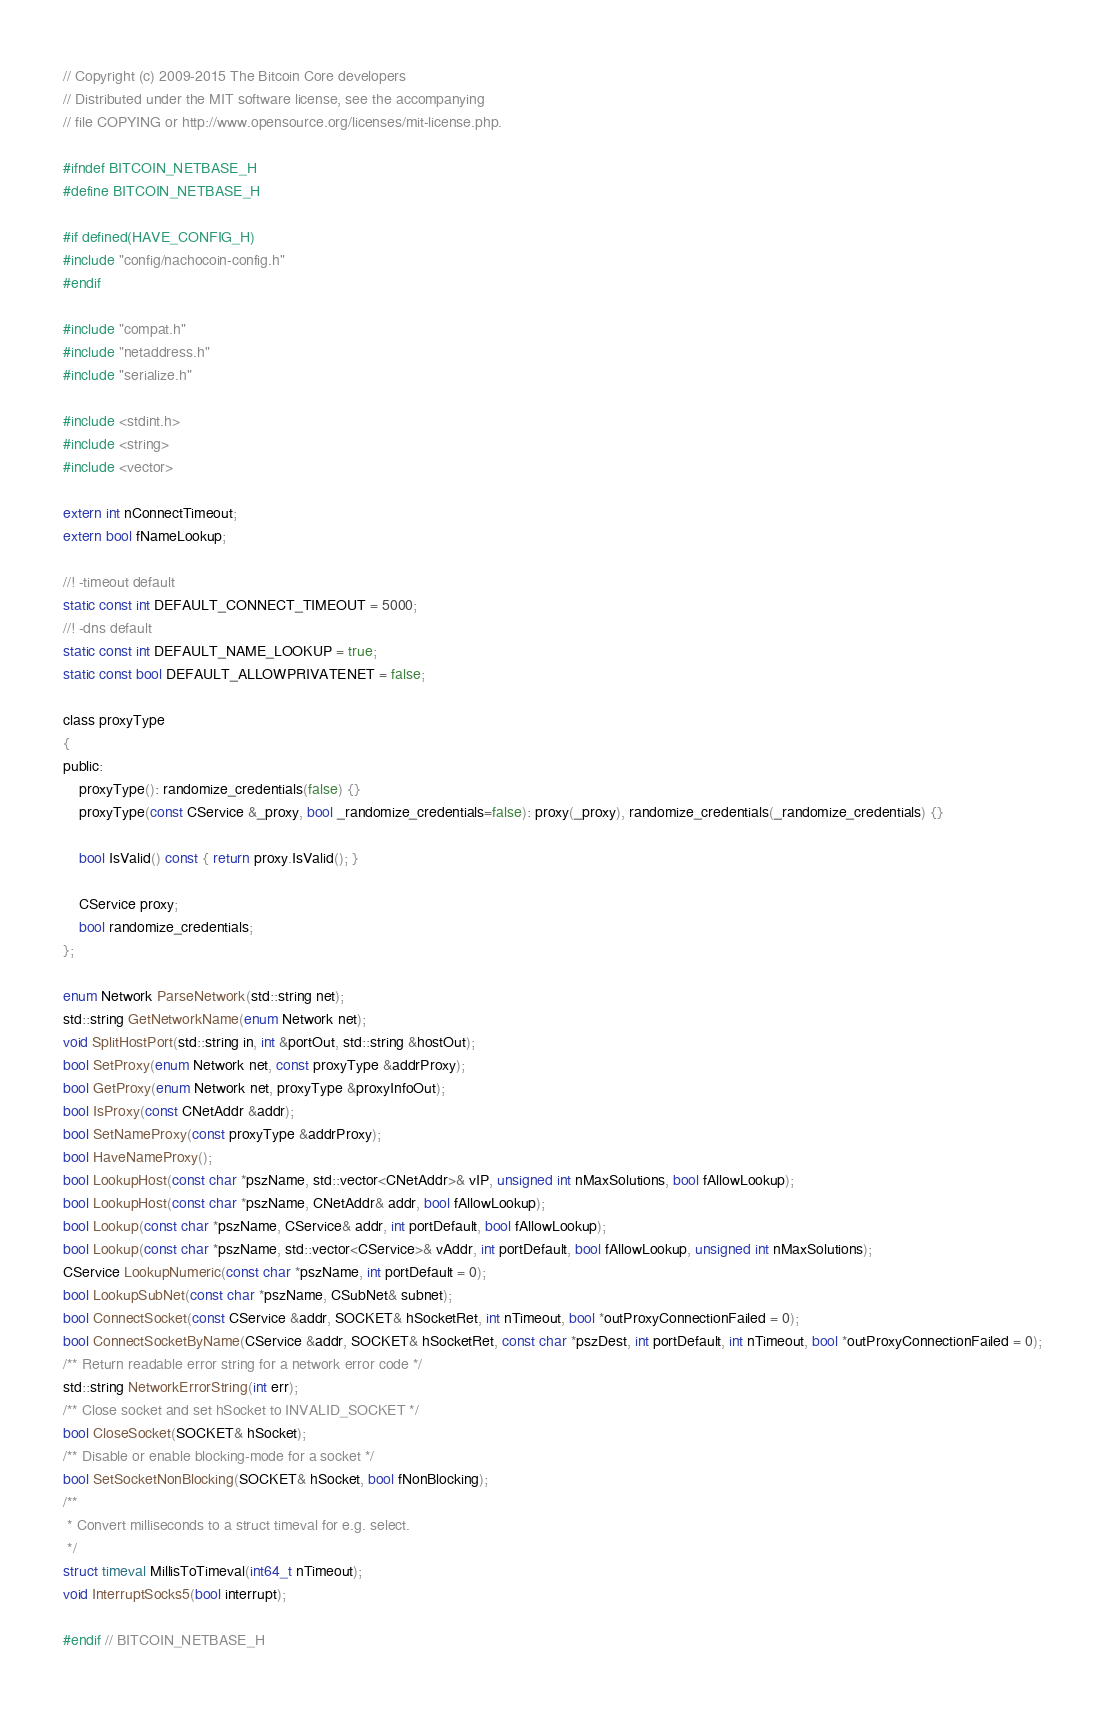Convert code to text. <code><loc_0><loc_0><loc_500><loc_500><_C_>// Copyright (c) 2009-2015 The Bitcoin Core developers
// Distributed under the MIT software license, see the accompanying
// file COPYING or http://www.opensource.org/licenses/mit-license.php.

#ifndef BITCOIN_NETBASE_H
#define BITCOIN_NETBASE_H

#if defined(HAVE_CONFIG_H)
#include "config/nachocoin-config.h"
#endif

#include "compat.h"
#include "netaddress.h"
#include "serialize.h"

#include <stdint.h>
#include <string>
#include <vector>

extern int nConnectTimeout;
extern bool fNameLookup;

//! -timeout default
static const int DEFAULT_CONNECT_TIMEOUT = 5000;
//! -dns default
static const int DEFAULT_NAME_LOOKUP = true;
static const bool DEFAULT_ALLOWPRIVATENET = false;

class proxyType
{
public:
    proxyType(): randomize_credentials(false) {}
    proxyType(const CService &_proxy, bool _randomize_credentials=false): proxy(_proxy), randomize_credentials(_randomize_credentials) {}

    bool IsValid() const { return proxy.IsValid(); }

    CService proxy;
    bool randomize_credentials;
};

enum Network ParseNetwork(std::string net);
std::string GetNetworkName(enum Network net);
void SplitHostPort(std::string in, int &portOut, std::string &hostOut);
bool SetProxy(enum Network net, const proxyType &addrProxy);
bool GetProxy(enum Network net, proxyType &proxyInfoOut);
bool IsProxy(const CNetAddr &addr);
bool SetNameProxy(const proxyType &addrProxy);
bool HaveNameProxy();
bool LookupHost(const char *pszName, std::vector<CNetAddr>& vIP, unsigned int nMaxSolutions, bool fAllowLookup);
bool LookupHost(const char *pszName, CNetAddr& addr, bool fAllowLookup);
bool Lookup(const char *pszName, CService& addr, int portDefault, bool fAllowLookup);
bool Lookup(const char *pszName, std::vector<CService>& vAddr, int portDefault, bool fAllowLookup, unsigned int nMaxSolutions);
CService LookupNumeric(const char *pszName, int portDefault = 0);
bool LookupSubNet(const char *pszName, CSubNet& subnet);
bool ConnectSocket(const CService &addr, SOCKET& hSocketRet, int nTimeout, bool *outProxyConnectionFailed = 0);
bool ConnectSocketByName(CService &addr, SOCKET& hSocketRet, const char *pszDest, int portDefault, int nTimeout, bool *outProxyConnectionFailed = 0);
/** Return readable error string for a network error code */
std::string NetworkErrorString(int err);
/** Close socket and set hSocket to INVALID_SOCKET */
bool CloseSocket(SOCKET& hSocket);
/** Disable or enable blocking-mode for a socket */
bool SetSocketNonBlocking(SOCKET& hSocket, bool fNonBlocking);
/**
 * Convert milliseconds to a struct timeval for e.g. select.
 */
struct timeval MillisToTimeval(int64_t nTimeout);
void InterruptSocks5(bool interrupt);

#endif // BITCOIN_NETBASE_H
</code> 